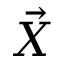Convert formula to latex. <formula><loc_0><loc_0><loc_500><loc_500>\vec { X }</formula> 